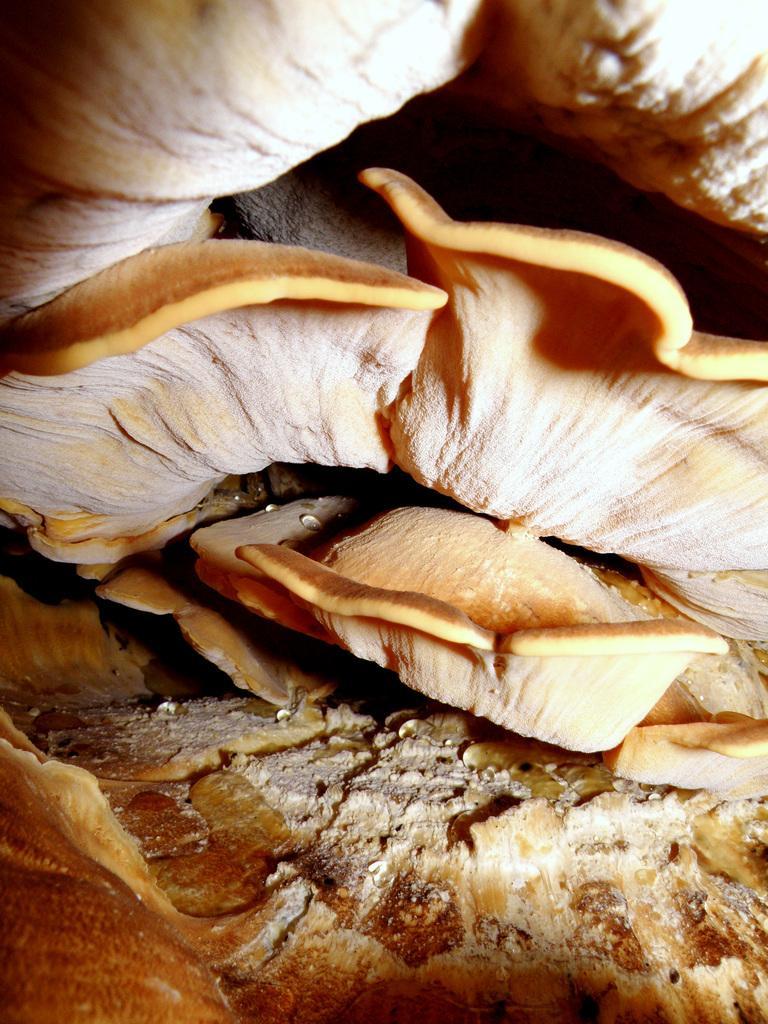In one or two sentences, can you explain what this image depicts? In this picture I can see mushroom. 